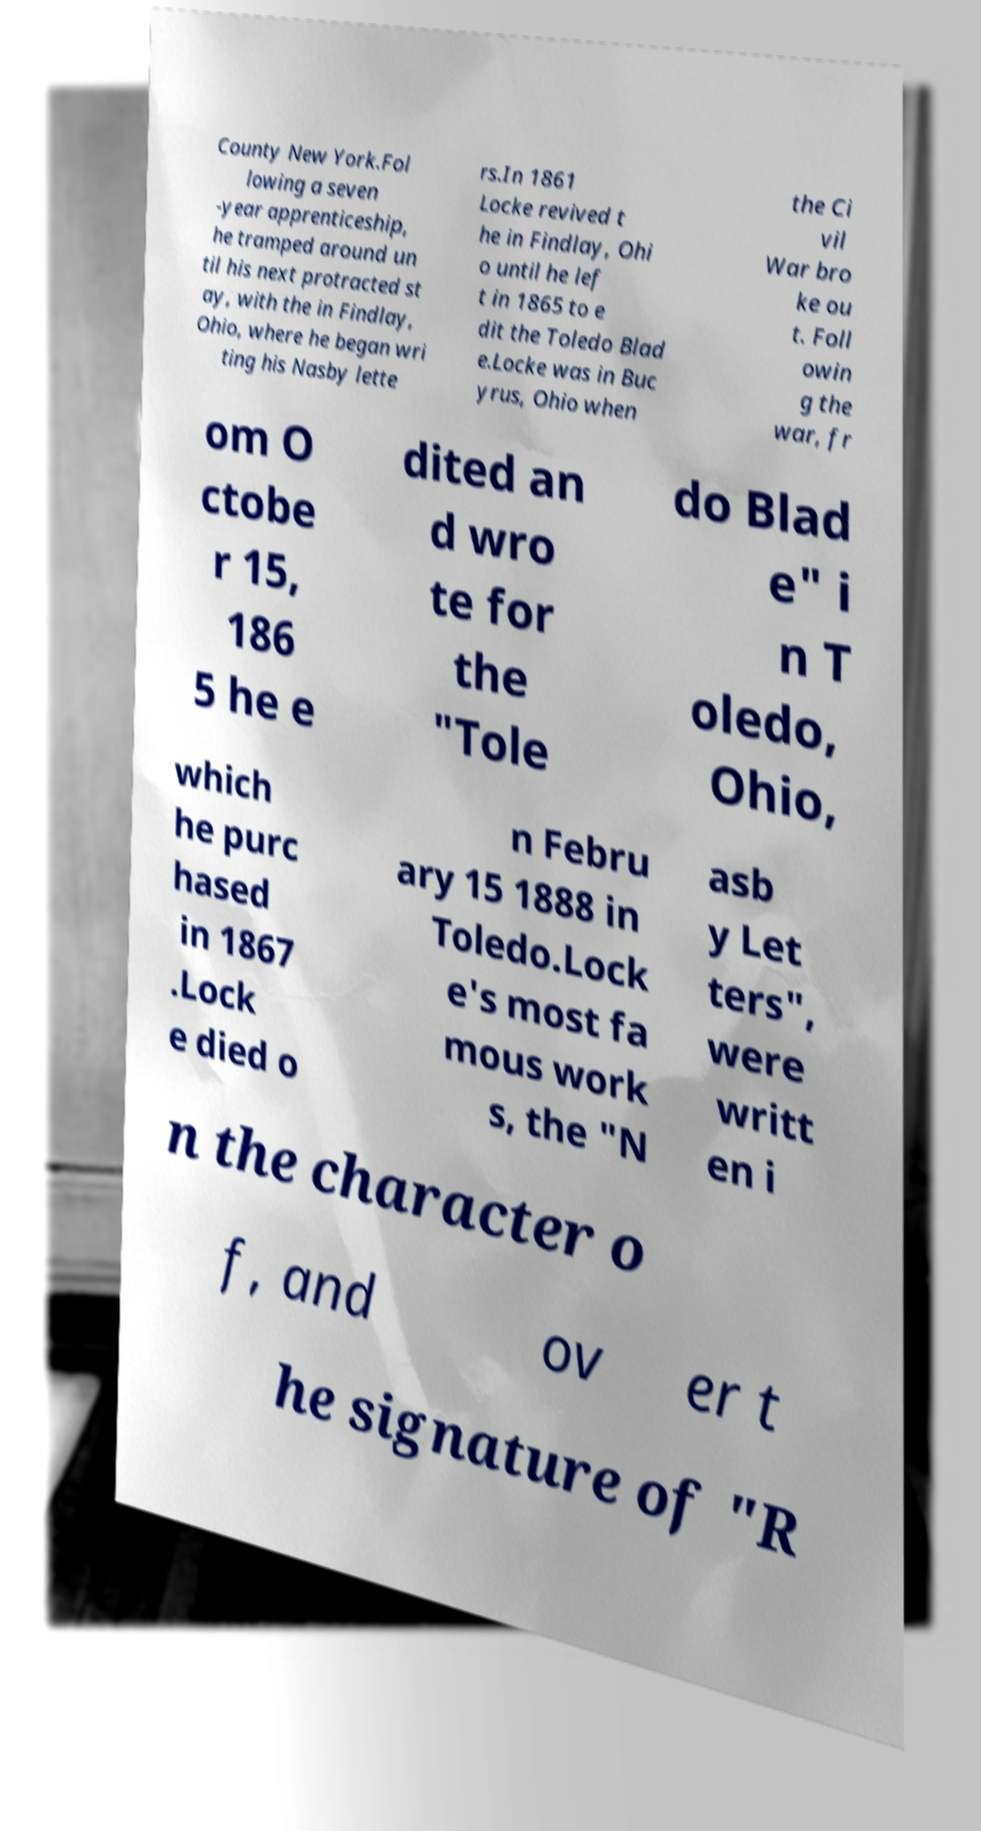Can you read and provide the text displayed in the image?This photo seems to have some interesting text. Can you extract and type it out for me? County New York.Fol lowing a seven -year apprenticeship, he tramped around un til his next protracted st ay, with the in Findlay, Ohio, where he began wri ting his Nasby lette rs.In 1861 Locke revived t he in Findlay, Ohi o until he lef t in 1865 to e dit the Toledo Blad e.Locke was in Buc yrus, Ohio when the Ci vil War bro ke ou t. Foll owin g the war, fr om O ctobe r 15, 186 5 he e dited an d wro te for the "Tole do Blad e" i n T oledo, Ohio, which he purc hased in 1867 .Lock e died o n Febru ary 15 1888 in Toledo.Lock e's most fa mous work s, the "N asb y Let ters", were writt en i n the character o f, and ov er t he signature of "R 